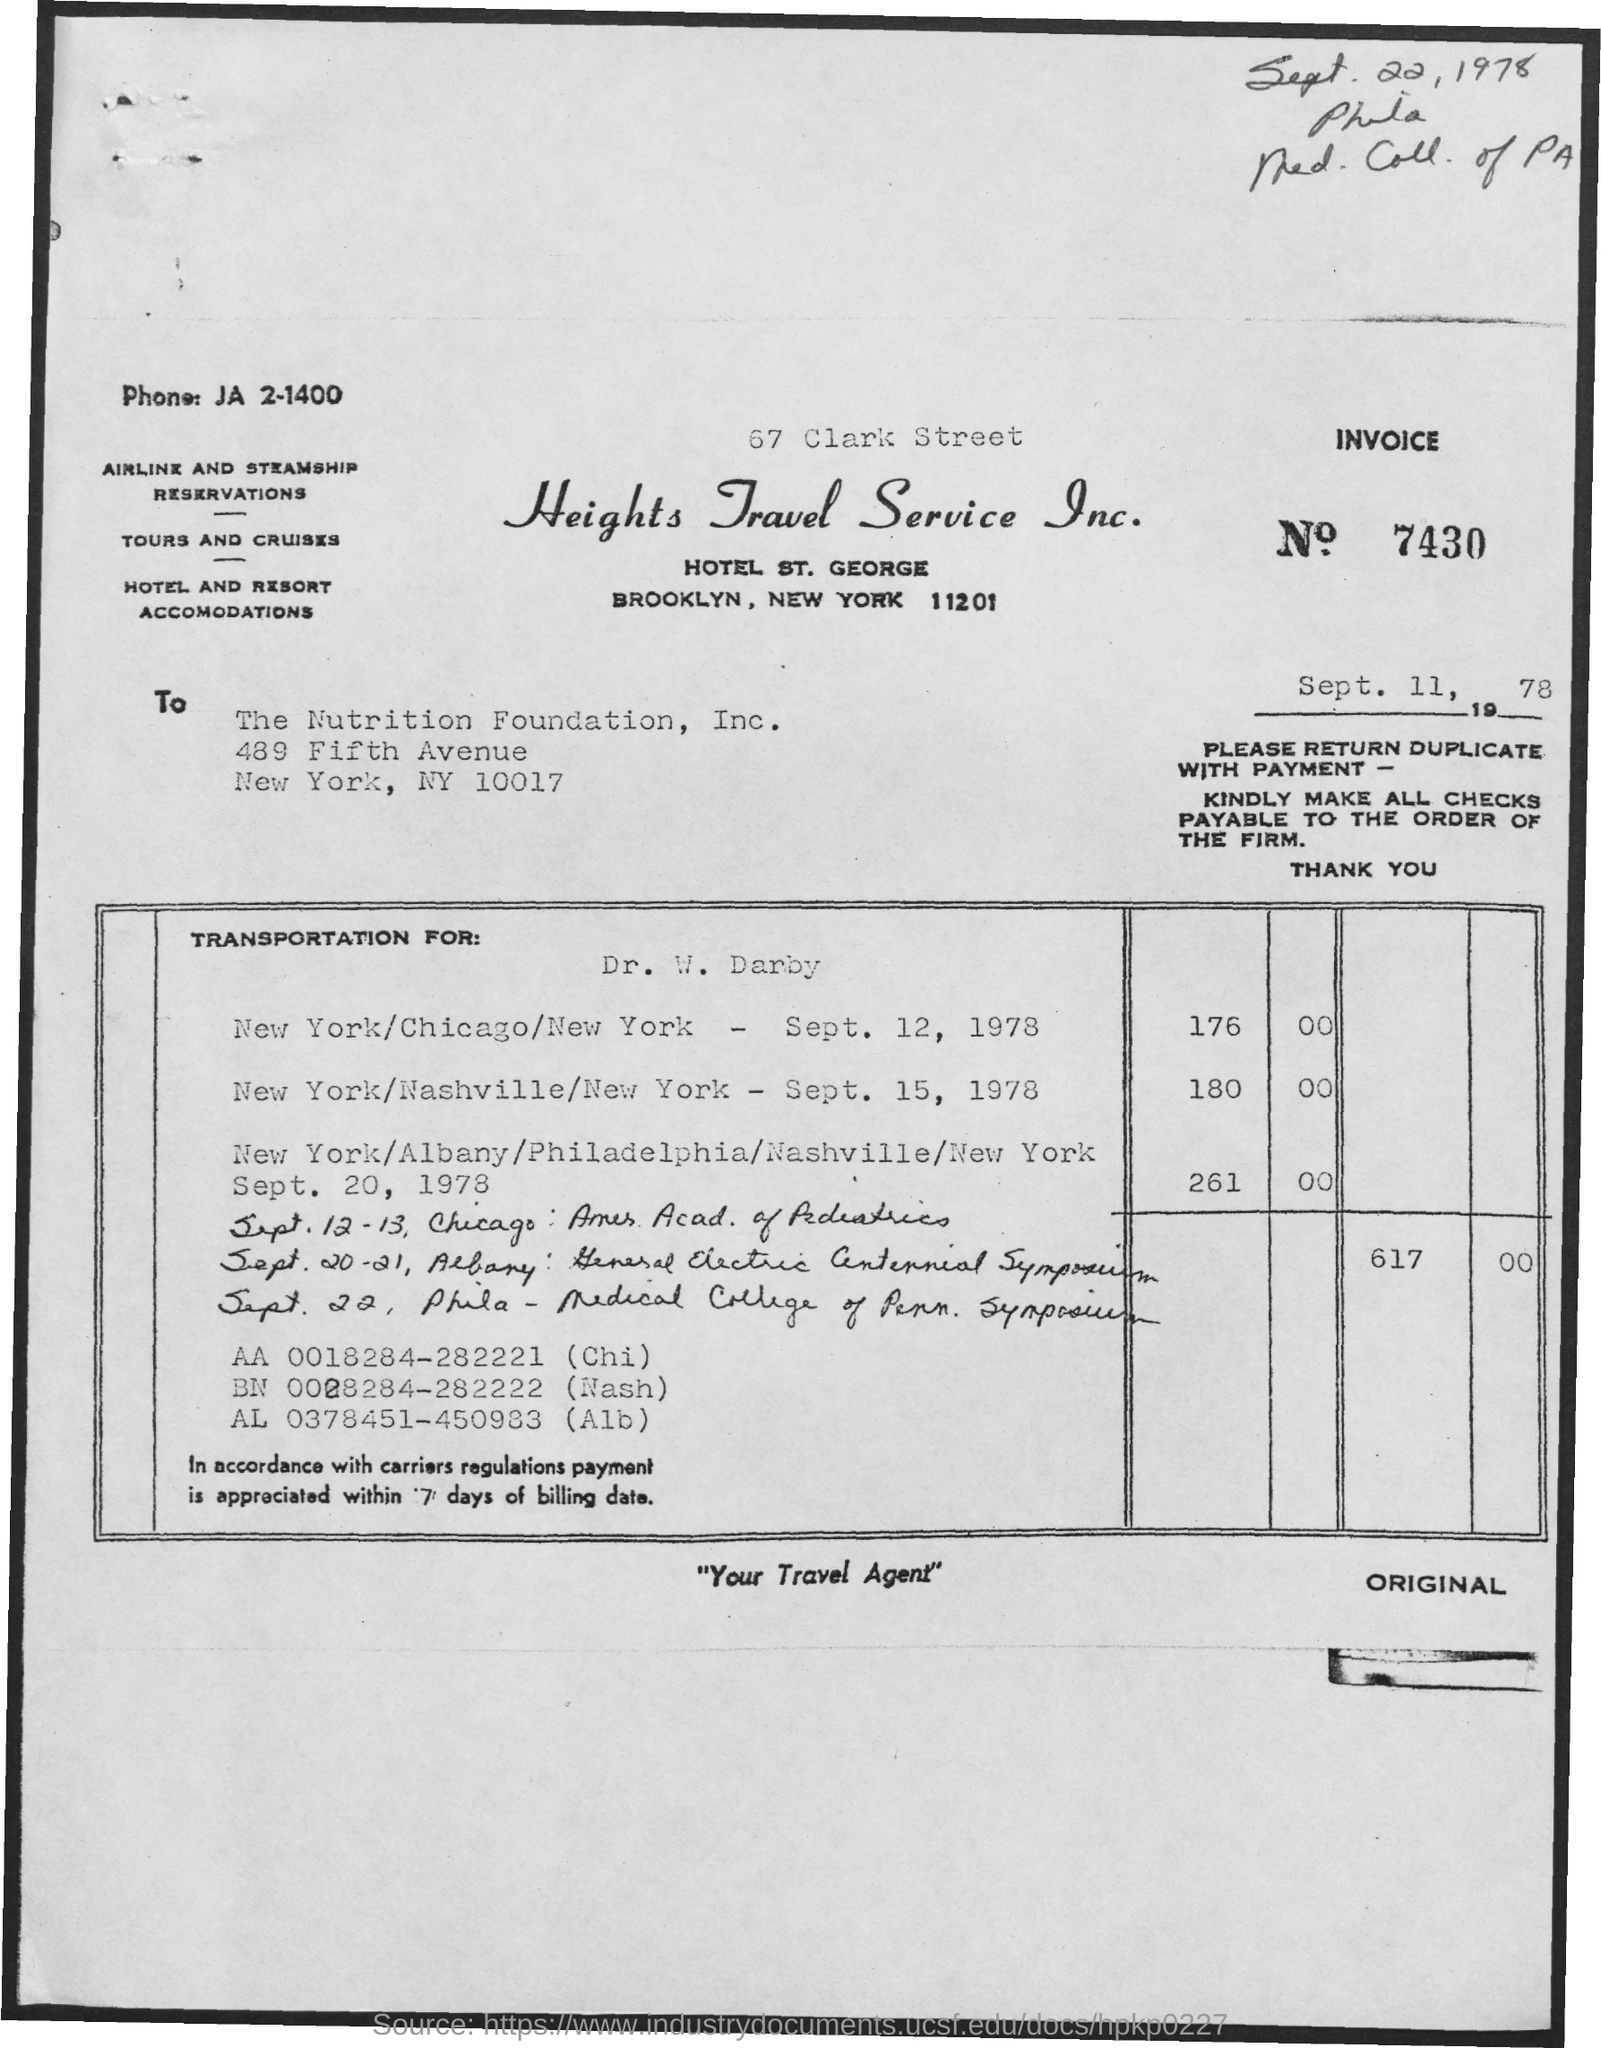Draw attention to some important aspects in this diagram. The date at the top right of the document is September 22, 1978. The date below the invoice number is September 11, 1978. The invoice number is 7430. 